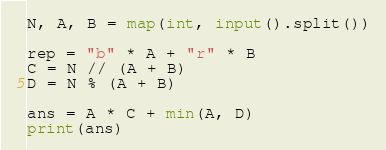<code> <loc_0><loc_0><loc_500><loc_500><_Python_>N, A, B = map(int, input().split())
 
rep = "b" * A + "r" * B
C = N // (A + B)
D = N % (A + B)
 
ans = A * C + min(A, D)
print(ans)</code> 